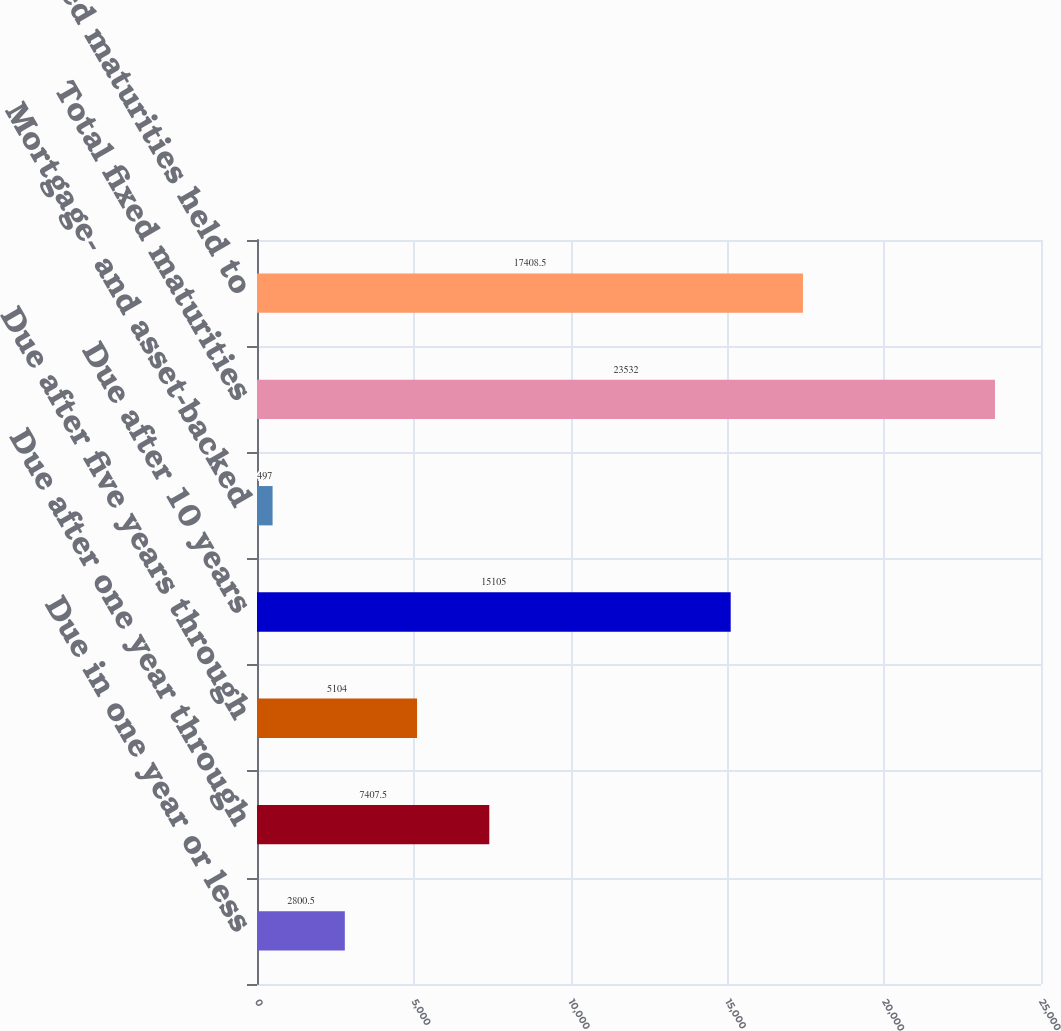<chart> <loc_0><loc_0><loc_500><loc_500><bar_chart><fcel>Due in one year or less<fcel>Due after one year through<fcel>Due after five years through<fcel>Due after 10 years<fcel>Mortgage- and asset-backed<fcel>Total fixed maturities<fcel>Total fixed maturities held to<nl><fcel>2800.5<fcel>7407.5<fcel>5104<fcel>15105<fcel>497<fcel>23532<fcel>17408.5<nl></chart> 